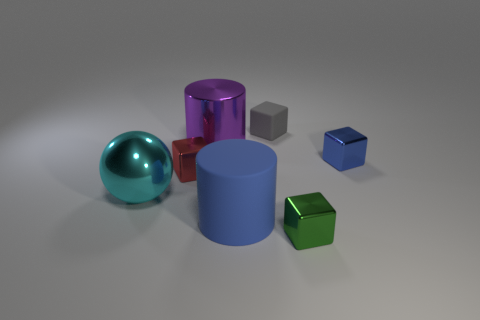Is there any other thing of the same color as the metallic cylinder?
Your answer should be very brief. No. How many objects are objects that are right of the big purple shiny object or blue cubes?
Your response must be concise. 4. There is a big cyan object that is the same material as the red object; what shape is it?
Offer a terse response. Sphere. How many other large objects are the same shape as the big purple object?
Offer a very short reply. 1. What material is the purple object?
Ensure brevity in your answer.  Metal. Is the color of the rubber cylinder the same as the metal block that is to the right of the green metallic cube?
Make the answer very short. Yes. How many spheres are cyan shiny objects or rubber objects?
Offer a very short reply. 1. There is a metallic cube left of the large blue cylinder; what is its color?
Keep it short and to the point. Red. What shape is the tiny shiny thing that is the same color as the big rubber cylinder?
Ensure brevity in your answer.  Cube. What number of cyan metal balls are the same size as the blue metallic thing?
Offer a terse response. 0. 